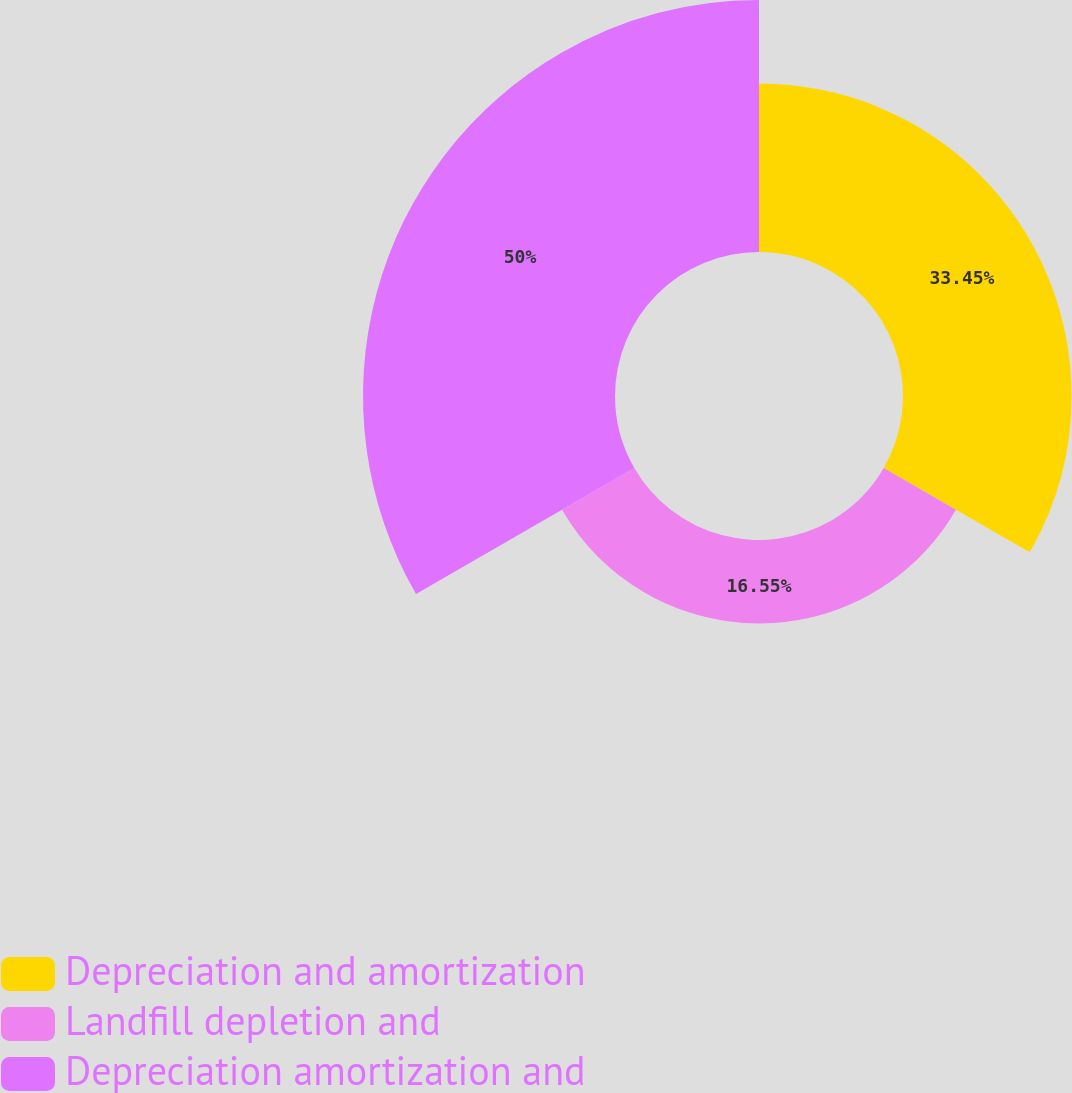Convert chart to OTSL. <chart><loc_0><loc_0><loc_500><loc_500><pie_chart><fcel>Depreciation and amortization<fcel>Landfill depletion and<fcel>Depreciation amortization and<nl><fcel>33.45%<fcel>16.55%<fcel>50.0%<nl></chart> 